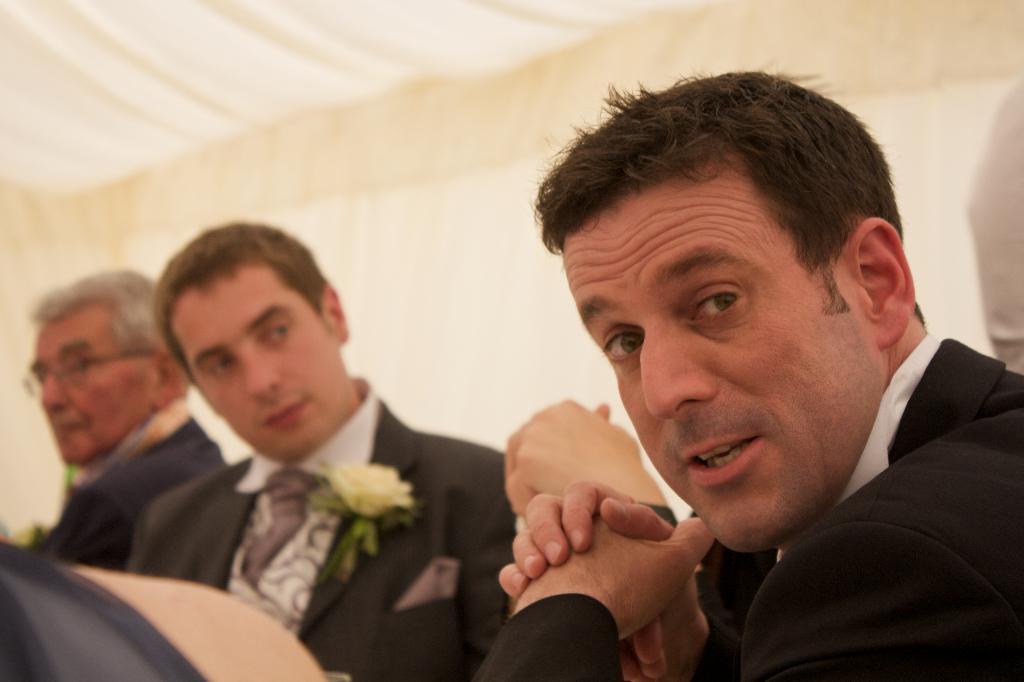Can you describe this image briefly? In this image I can see four persons, flower, papers and wall. This image is taken may be in a hall. 